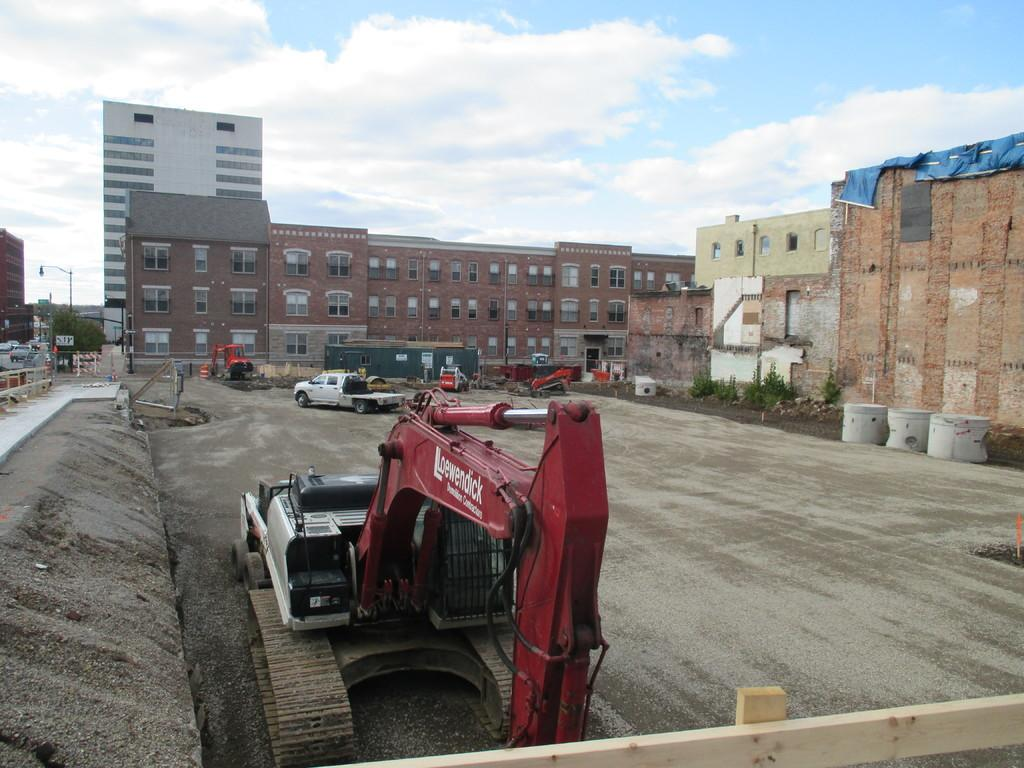What type of structures can be seen in the image? There are buildings in the image. What else is present in the image besides buildings? There are vehicles, a bulldozer, plants, and a pole on the left side of the image. Can you describe the left side of the image? On the left side of the image, there is a pole, barricades, and trees. What is visible in the background of the image? The sky is visible in the background of the image. What type of yard is visible in the image? There is no yard present in the image. What team is responsible for the construction work in the image? There is no team visible in the image, and no construction work is explicitly mentioned. 